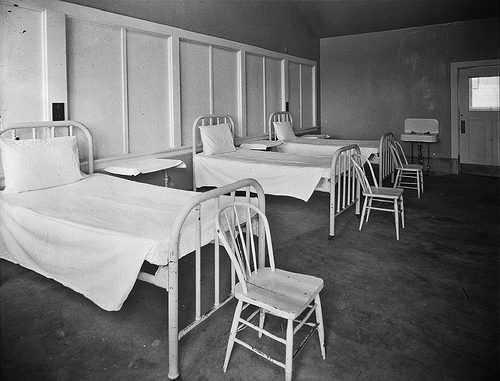What era does this room seem to come from? The room's design and the photographic quality suggest it could date back to the early to mid-20th century, a time when medical facilities often had a more austere and utilitarian appearance compared to modern standards. 